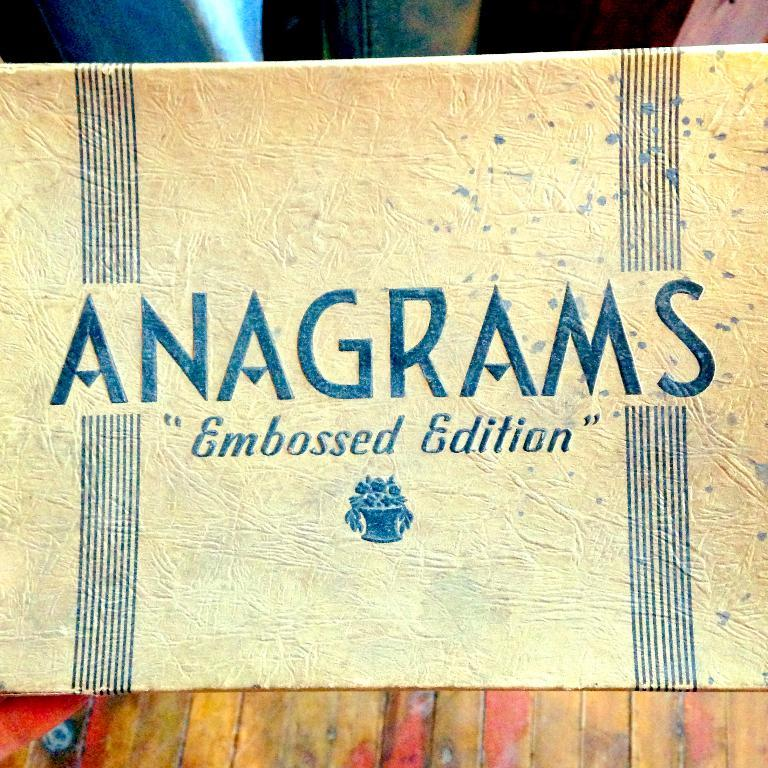<image>
Describe the image concisely. A dirty battered box is labeled with ANAGRAMS Embossed Edition. 